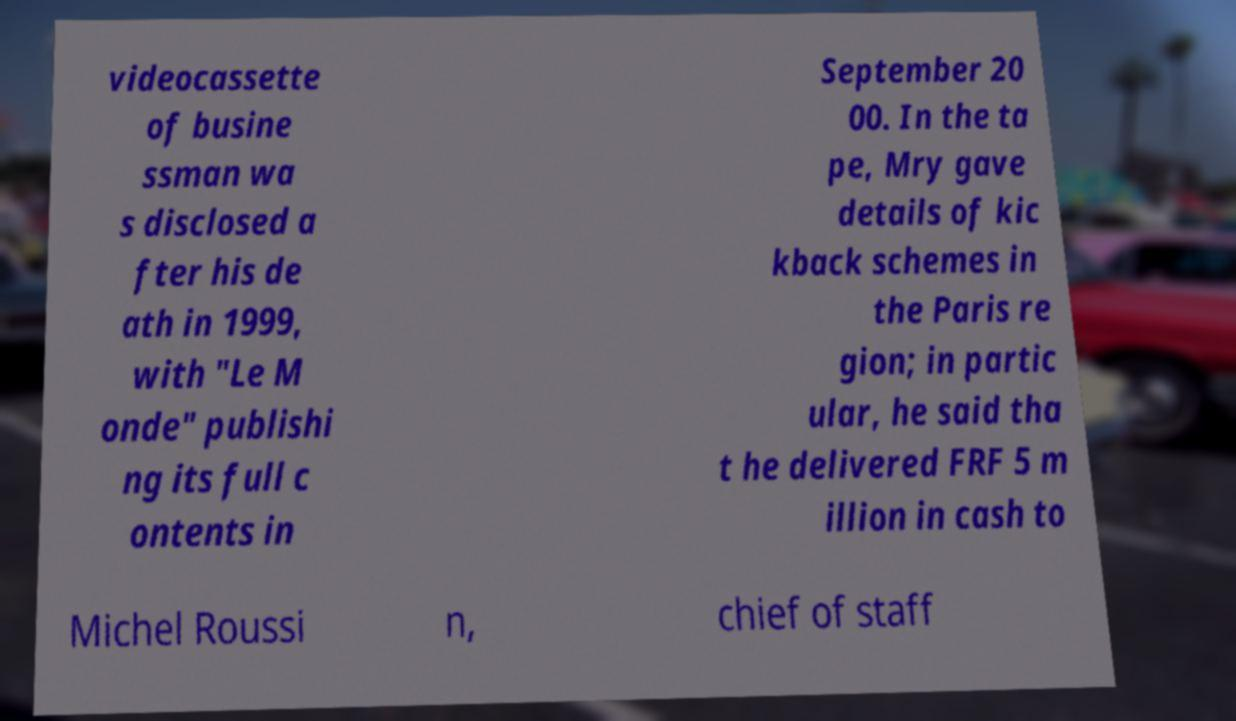Can you accurately transcribe the text from the provided image for me? videocassette of busine ssman wa s disclosed a fter his de ath in 1999, with "Le M onde" publishi ng its full c ontents in September 20 00. In the ta pe, Mry gave details of kic kback schemes in the Paris re gion; in partic ular, he said tha t he delivered FRF 5 m illion in cash to Michel Roussi n, chief of staff 